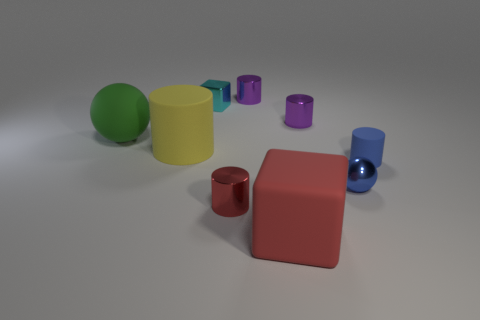Is the big yellow matte thing the same shape as the small cyan metal object?
Ensure brevity in your answer.  No. There is a small cylinder that is right of the purple metallic thing to the right of the big red object; what number of purple shiny objects are in front of it?
Provide a succinct answer. 0. What material is the object that is on the left side of the tiny red shiny cylinder and on the right side of the yellow rubber cylinder?
Ensure brevity in your answer.  Metal. There is a object that is behind the red rubber block and in front of the blue metal thing; what color is it?
Keep it short and to the point. Red. Is there any other thing that has the same color as the metallic block?
Your response must be concise. No. What is the shape of the purple metallic thing that is behind the tiny purple cylinder that is in front of the purple object that is behind the small cyan metallic object?
Give a very brief answer. Cylinder. What is the color of the small thing that is the same shape as the big green rubber object?
Your response must be concise. Blue. What is the color of the matte thing that is on the right side of the large object in front of the small metallic sphere?
Offer a terse response. Blue. There is a blue matte object that is the same shape as the tiny red object; what size is it?
Provide a short and direct response. Small. How many small red cylinders are the same material as the green object?
Ensure brevity in your answer.  0. 